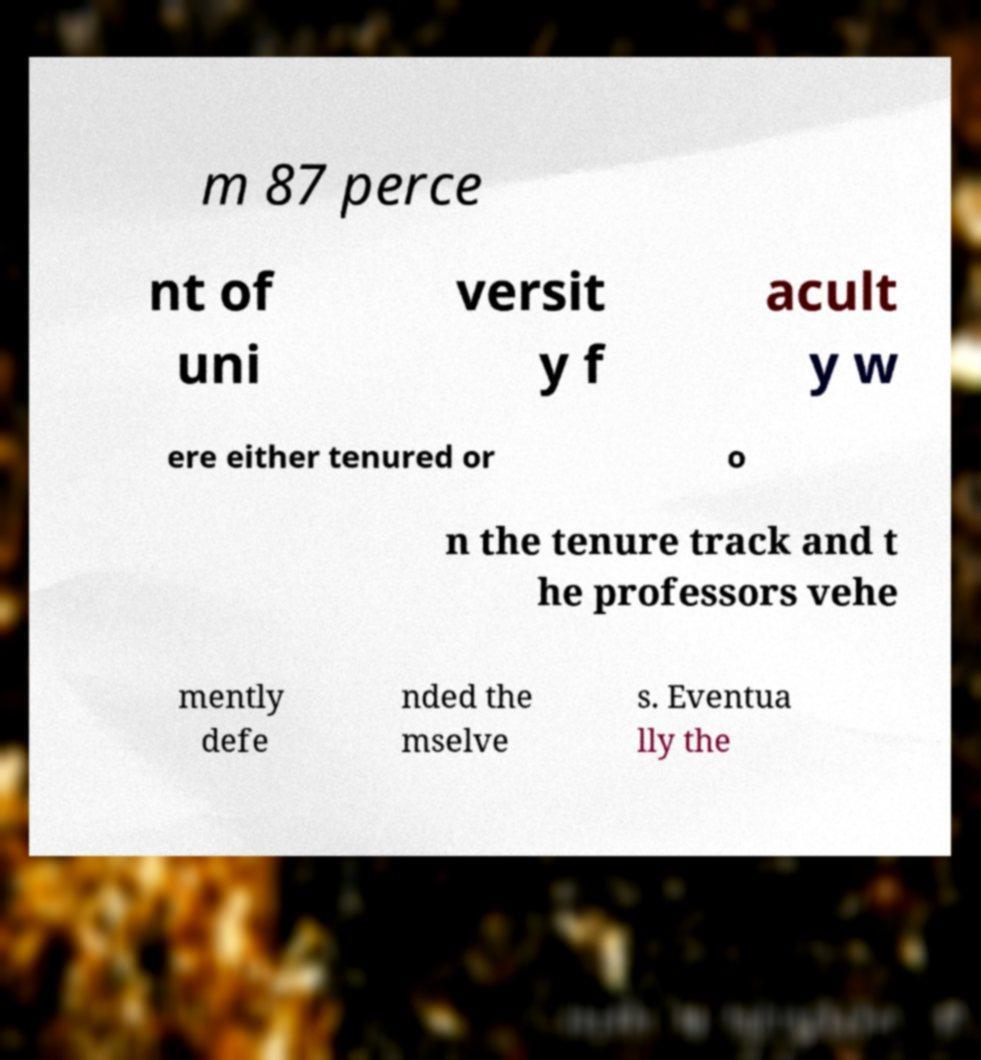Could you assist in decoding the text presented in this image and type it out clearly? m 87 perce nt of uni versit y f acult y w ere either tenured or o n the tenure track and t he professors vehe mently defe nded the mselve s. Eventua lly the 